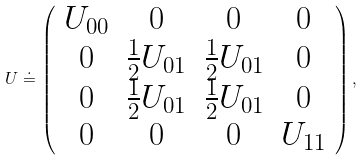Convert formula to latex. <formula><loc_0><loc_0><loc_500><loc_500>U \doteq \left ( \begin{array} { c c c c } U _ { 0 0 } & 0 & 0 & 0 \\ 0 & \frac { 1 } { 2 } U _ { 0 1 } & \frac { 1 } { 2 } U _ { 0 1 } & 0 \\ 0 & \frac { 1 } { 2 } U _ { 0 1 } & \frac { 1 } { 2 } U _ { 0 1 } & 0 \\ 0 & 0 & 0 & U _ { 1 1 } \end{array} \right ) ,</formula> 